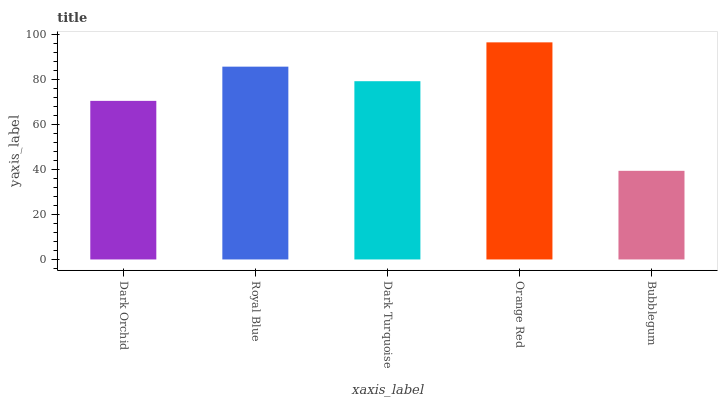Is Royal Blue the minimum?
Answer yes or no. No. Is Royal Blue the maximum?
Answer yes or no. No. Is Royal Blue greater than Dark Orchid?
Answer yes or no. Yes. Is Dark Orchid less than Royal Blue?
Answer yes or no. Yes. Is Dark Orchid greater than Royal Blue?
Answer yes or no. No. Is Royal Blue less than Dark Orchid?
Answer yes or no. No. Is Dark Turquoise the high median?
Answer yes or no. Yes. Is Dark Turquoise the low median?
Answer yes or no. Yes. Is Dark Orchid the high median?
Answer yes or no. No. Is Bubblegum the low median?
Answer yes or no. No. 